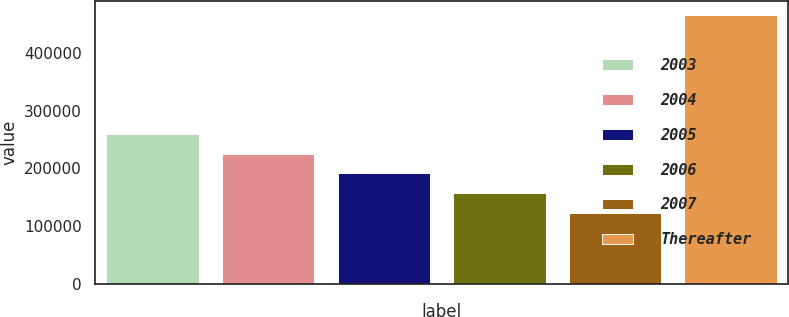Convert chart. <chart><loc_0><loc_0><loc_500><loc_500><bar_chart><fcel>2003<fcel>2004<fcel>2005<fcel>2006<fcel>2007<fcel>Thereafter<nl><fcel>260132<fcel>225762<fcel>191393<fcel>157023<fcel>122654<fcel>466348<nl></chart> 